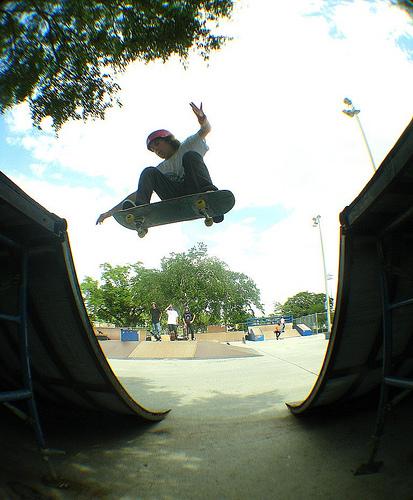Are there shadows in the image?
Keep it brief. Yes. Is this person wearing a helmet?
Answer briefly. Yes. What color is the person's shirt?
Keep it brief. White. 